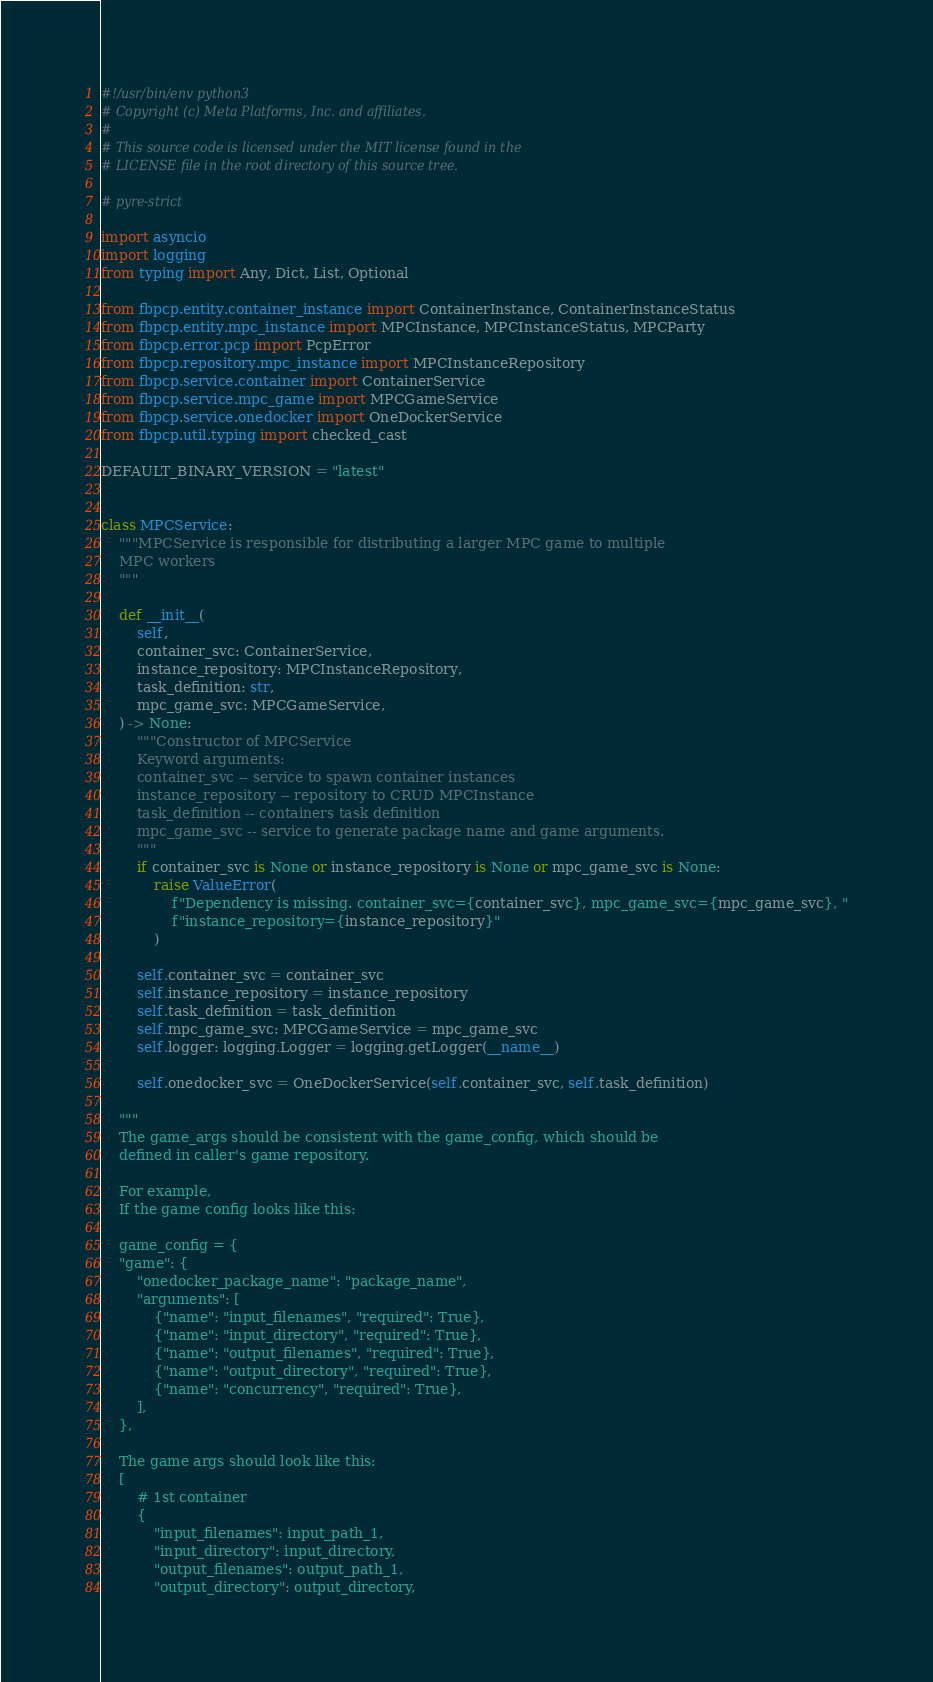Convert code to text. <code><loc_0><loc_0><loc_500><loc_500><_Python_>#!/usr/bin/env python3
# Copyright (c) Meta Platforms, Inc. and affiliates.
#
# This source code is licensed under the MIT license found in the
# LICENSE file in the root directory of this source tree.

# pyre-strict

import asyncio
import logging
from typing import Any, Dict, List, Optional

from fbpcp.entity.container_instance import ContainerInstance, ContainerInstanceStatus
from fbpcp.entity.mpc_instance import MPCInstance, MPCInstanceStatus, MPCParty
from fbpcp.error.pcp import PcpError
from fbpcp.repository.mpc_instance import MPCInstanceRepository
from fbpcp.service.container import ContainerService
from fbpcp.service.mpc_game import MPCGameService
from fbpcp.service.onedocker import OneDockerService
from fbpcp.util.typing import checked_cast

DEFAULT_BINARY_VERSION = "latest"


class MPCService:
    """MPCService is responsible for distributing a larger MPC game to multiple
    MPC workers
    """

    def __init__(
        self,
        container_svc: ContainerService,
        instance_repository: MPCInstanceRepository,
        task_definition: str,
        mpc_game_svc: MPCGameService,
    ) -> None:
        """Constructor of MPCService
        Keyword arguments:
        container_svc -- service to spawn container instances
        instance_repository -- repository to CRUD MPCInstance
        task_definition -- containers task definition
        mpc_game_svc -- service to generate package name and game arguments.
        """
        if container_svc is None or instance_repository is None or mpc_game_svc is None:
            raise ValueError(
                f"Dependency is missing. container_svc={container_svc}, mpc_game_svc={mpc_game_svc}, "
                f"instance_repository={instance_repository}"
            )

        self.container_svc = container_svc
        self.instance_repository = instance_repository
        self.task_definition = task_definition
        self.mpc_game_svc: MPCGameService = mpc_game_svc
        self.logger: logging.Logger = logging.getLogger(__name__)

        self.onedocker_svc = OneDockerService(self.container_svc, self.task_definition)

    """
    The game_args should be consistent with the game_config, which should be
    defined in caller's game repository.

    For example,
    If the game config looks like this:

    game_config = {
    "game": {
        "onedocker_package_name": "package_name",
        "arguments": [
            {"name": "input_filenames", "required": True},
            {"name": "input_directory", "required": True},
            {"name": "output_filenames", "required": True},
            {"name": "output_directory", "required": True},
            {"name": "concurrency", "required": True},
        ],
    },

    The game args should look like this:
    [
        # 1st container
        {
            "input_filenames": input_path_1,
            "input_directory": input_directory,
            "output_filenames": output_path_1,
            "output_directory": output_directory,</code> 